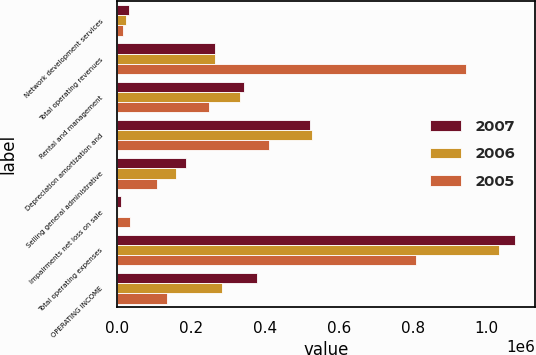<chart> <loc_0><loc_0><loc_500><loc_500><stacked_bar_chart><ecel><fcel>Network development services<fcel>Total operating revenues<fcel>Rental and management<fcel>Depreciation amortization and<fcel>Selling general administrative<fcel>Impairments net loss on sale<fcel>Total operating expenses<fcel>OPERATING INCOME<nl><fcel>2007<fcel>30619<fcel>265841<fcel>343450<fcel>522928<fcel>186483<fcel>9198<fcel>1.07823e+06<fcel>378363<nl><fcel>2006<fcel>23317<fcel>265841<fcel>332246<fcel>528051<fcel>159324<fcel>2572<fcel>1.03348e+06<fcel>283901<nl><fcel>2005<fcel>15024<fcel>944786<fcel>247781<fcel>411254<fcel>108059<fcel>34232<fcel>809672<fcel>135114<nl></chart> 